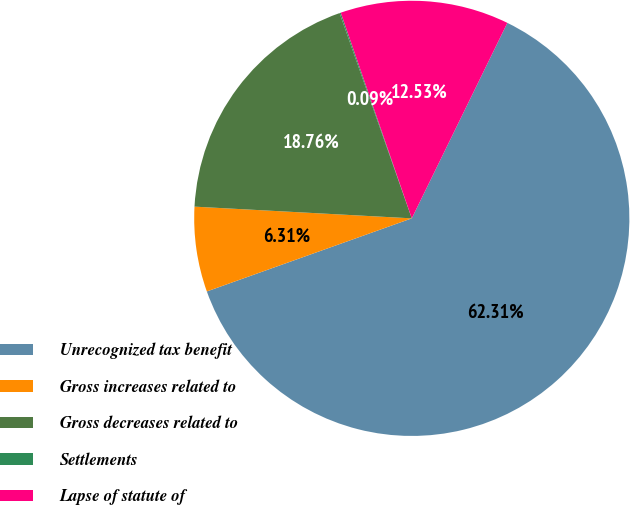<chart> <loc_0><loc_0><loc_500><loc_500><pie_chart><fcel>Unrecognized tax benefit<fcel>Gross increases related to<fcel>Gross decreases related to<fcel>Settlements<fcel>Lapse of statute of<nl><fcel>62.31%<fcel>6.31%<fcel>18.76%<fcel>0.09%<fcel>12.53%<nl></chart> 